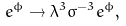<formula> <loc_0><loc_0><loc_500><loc_500>{ e ^ { \phi } \rightarrow { \lambda } ^ { 3 } { \sigma } ^ { - 3 } e ^ { \phi } , }</formula> 